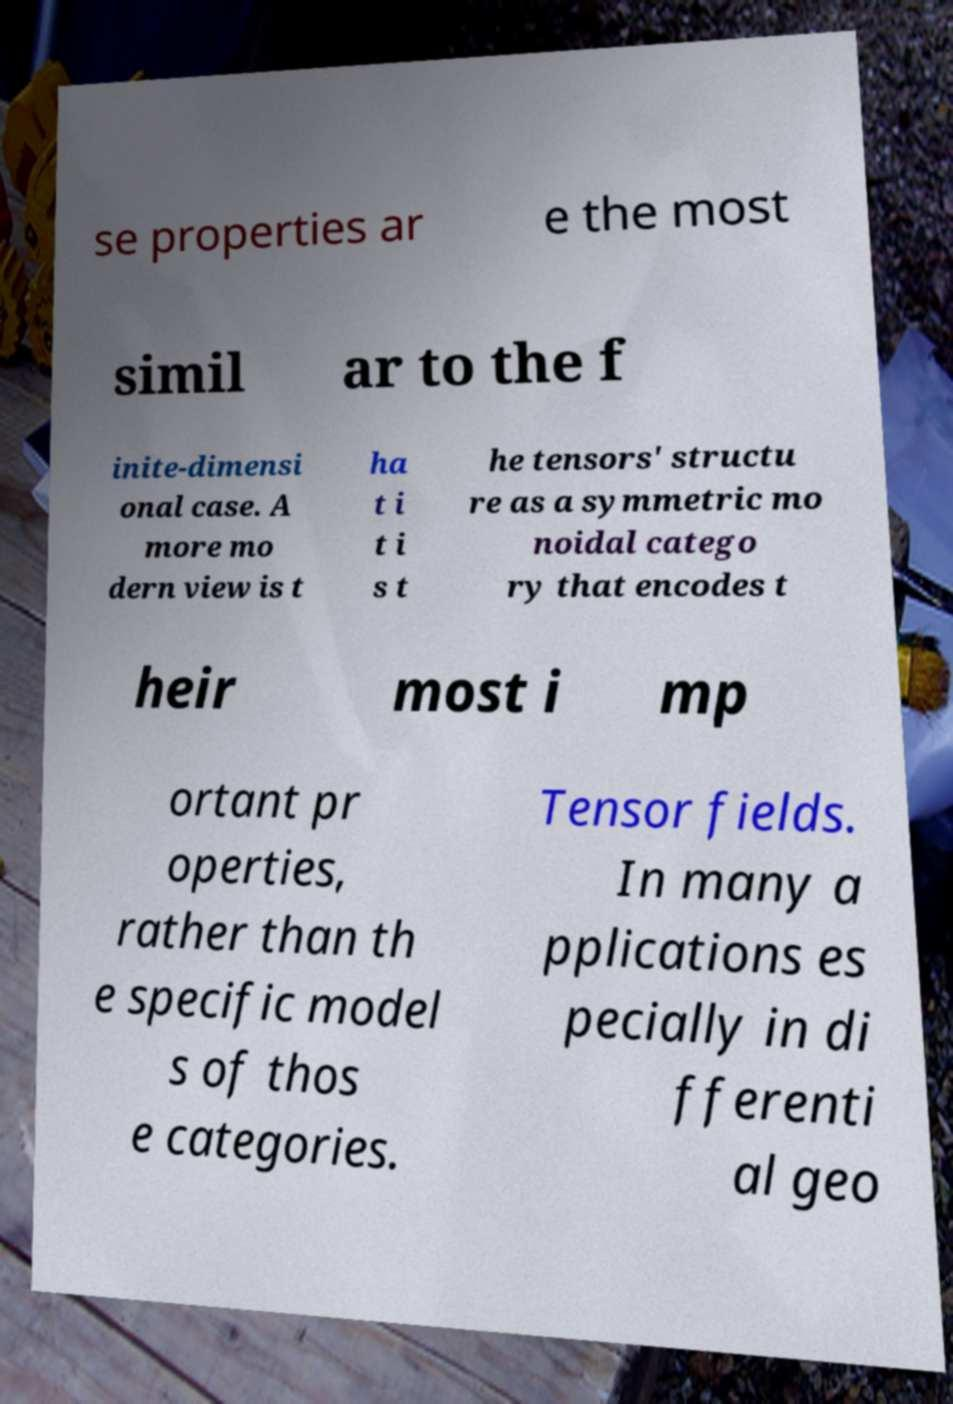What messages or text are displayed in this image? I need them in a readable, typed format. se properties ar e the most simil ar to the f inite-dimensi onal case. A more mo dern view is t ha t i t i s t he tensors' structu re as a symmetric mo noidal catego ry that encodes t heir most i mp ortant pr operties, rather than th e specific model s of thos e categories. Tensor fields. In many a pplications es pecially in di fferenti al geo 